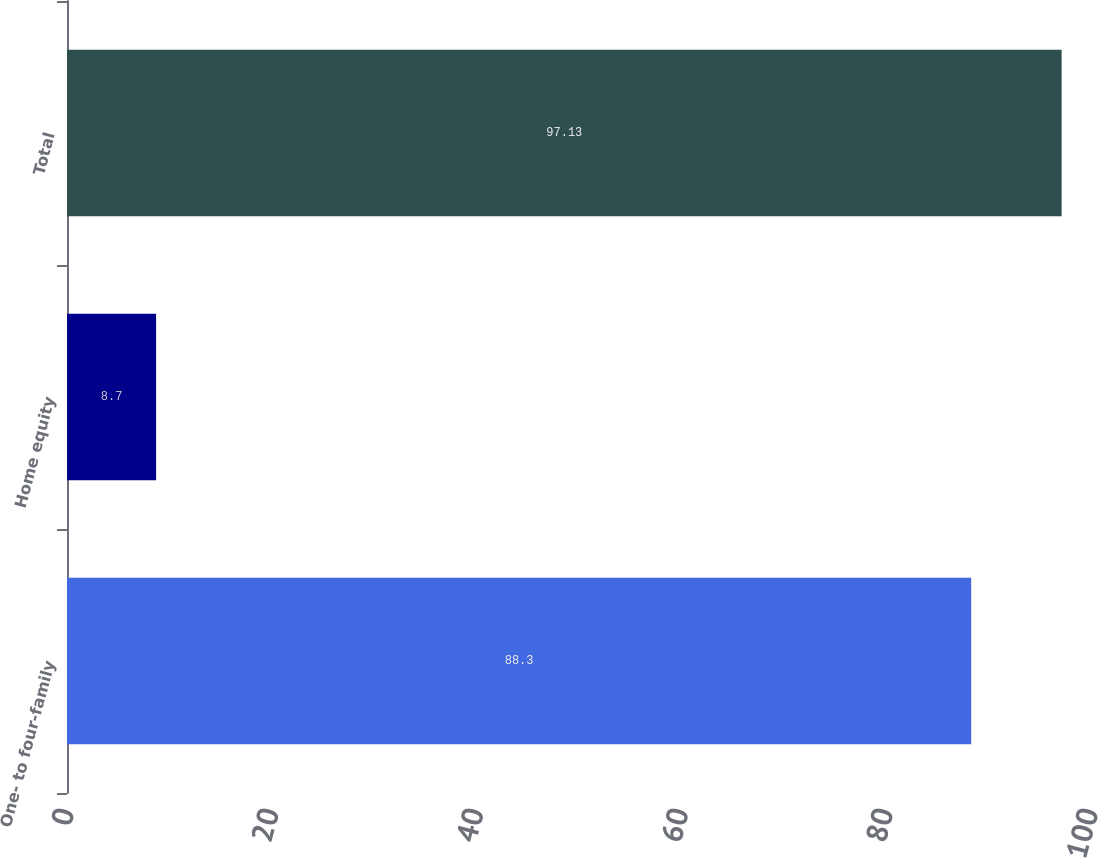<chart> <loc_0><loc_0><loc_500><loc_500><bar_chart><fcel>One- to four-family<fcel>Home equity<fcel>Total<nl><fcel>88.3<fcel>8.7<fcel>97.13<nl></chart> 